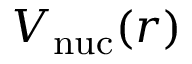<formula> <loc_0><loc_0><loc_500><loc_500>V _ { n u c } ( r )</formula> 